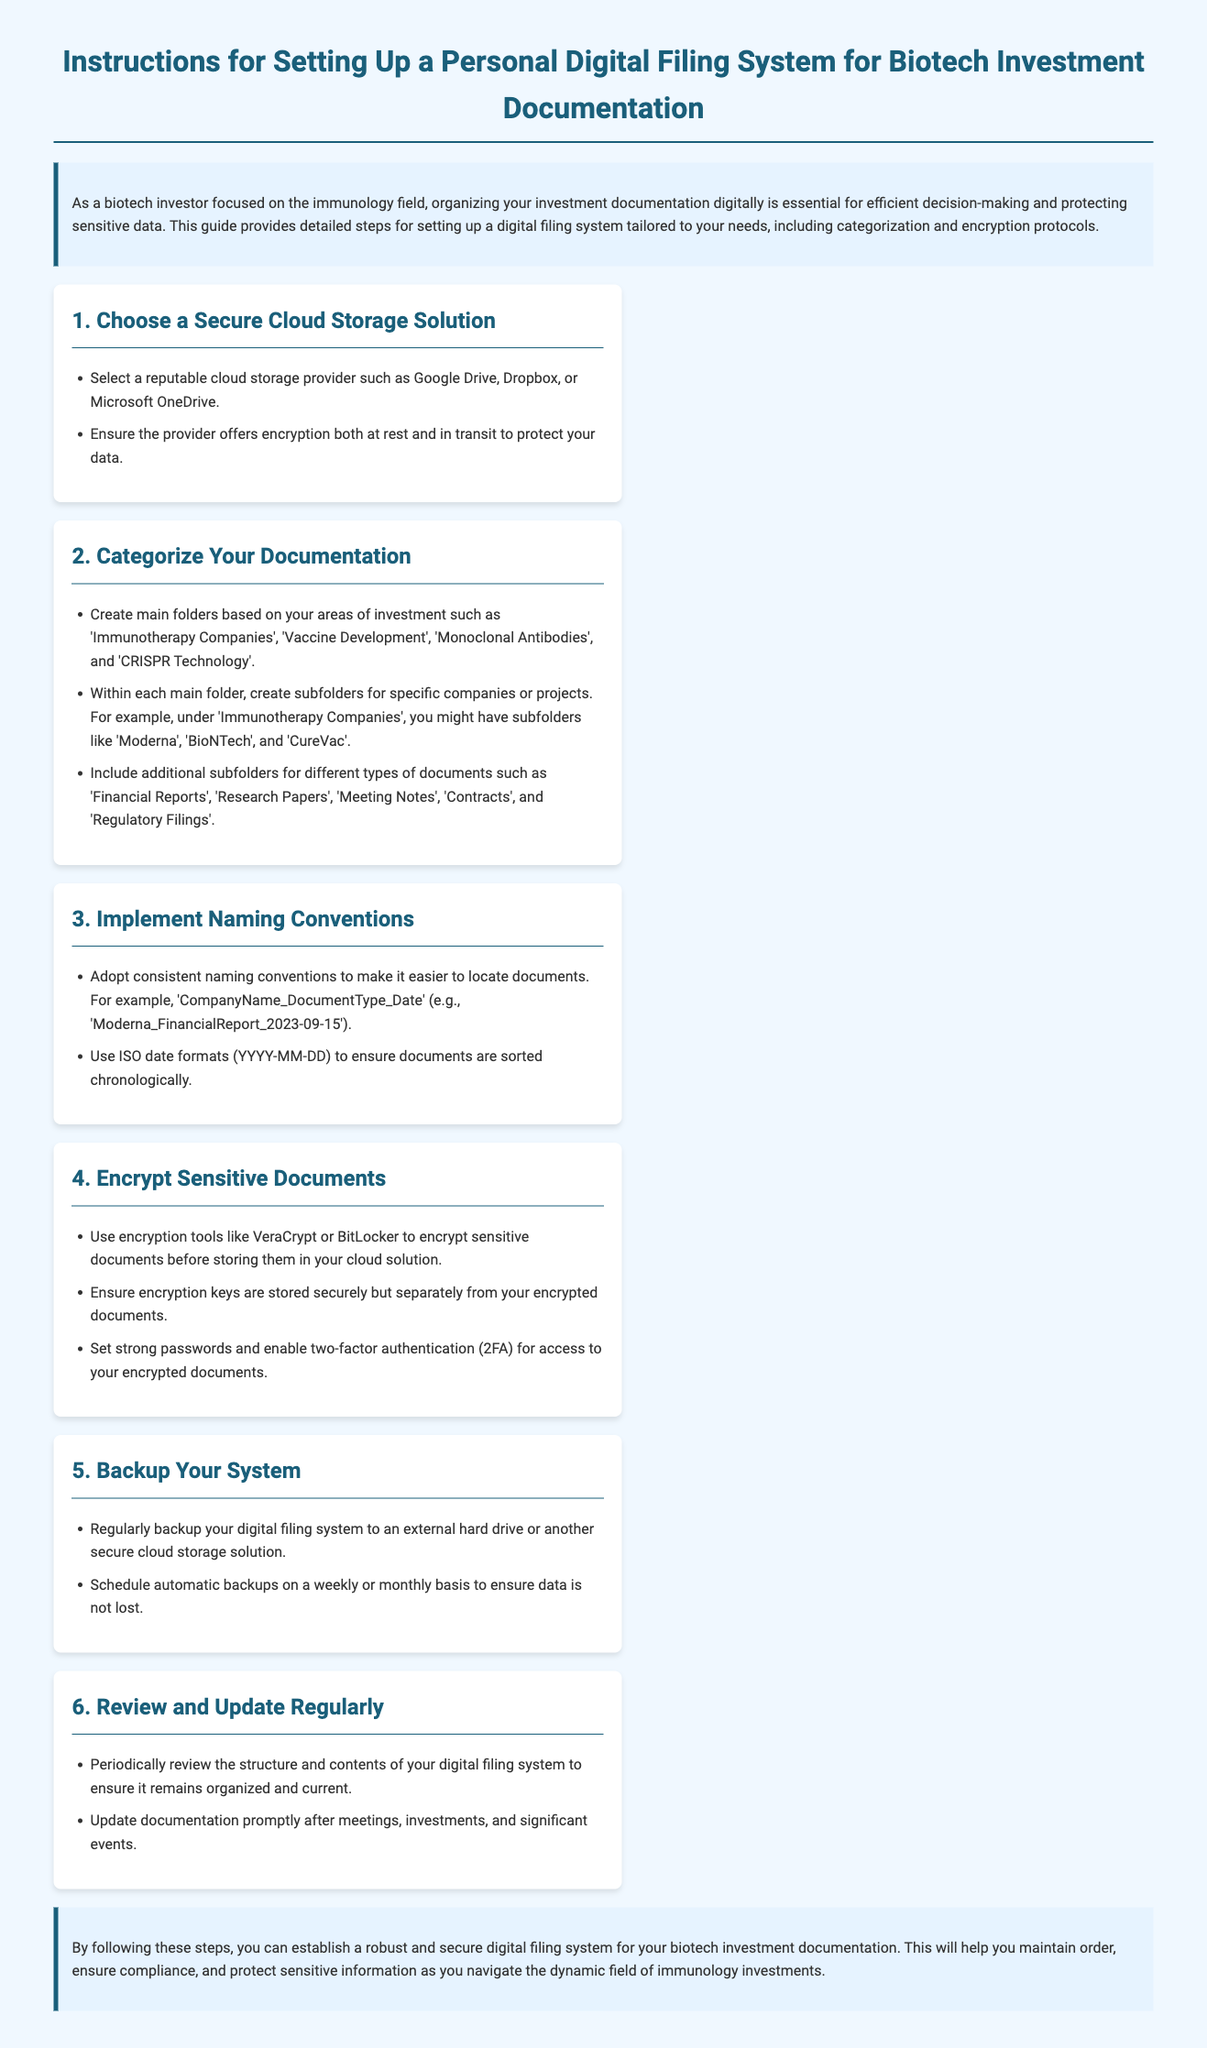What is the first step in setting up the filing system? The first step listed in the instructions is to choose a secure cloud storage solution.
Answer: Choose a Secure Cloud Storage Solution Which folders are suggested for categorizing documentation? The document suggests creating main folders such as 'Immunotherapy Companies', 'Vaccine Development', 'Monoclonal Antibodies', and 'CRISPR Technology'.
Answer: Main folders What is the recommended file naming convention? The document recommends a naming convention of 'CompanyName_DocumentType_Date'.
Answer: CompanyName_DocumentType_Date How often should backups be scheduled? According to the instructions, backups should be scheduled on a weekly or monthly basis.
Answer: Weekly or monthly What type of encryption tools are mentioned? The document mentions using tools like VeraCrypt or BitLocker for encryption.
Answer: VeraCrypt or BitLocker Why is two-factor authentication important? Two-factor authentication is mentioned as a security measure to ensure that access to encrypted documents is protected.
Answer: Security measure What is the purpose of reviewing the filing system? The purpose of reviewing the filing system is to ensure it remains organized and current.
Answer: Ensure organization and currency How should encryption keys be stored? Encryption keys should be stored securely but separately from your encrypted documents.
Answer: Securely but separately What type of documentation should be included in additional subfolders? The document specifies including types of documents such as 'Financial Reports', 'Research Papers', 'Meeting Notes', 'Contracts', and 'Regulatory Filings'.
Answer: Financial Reports, Research Papers, Meeting Notes, Contracts, Regulatory Filings 